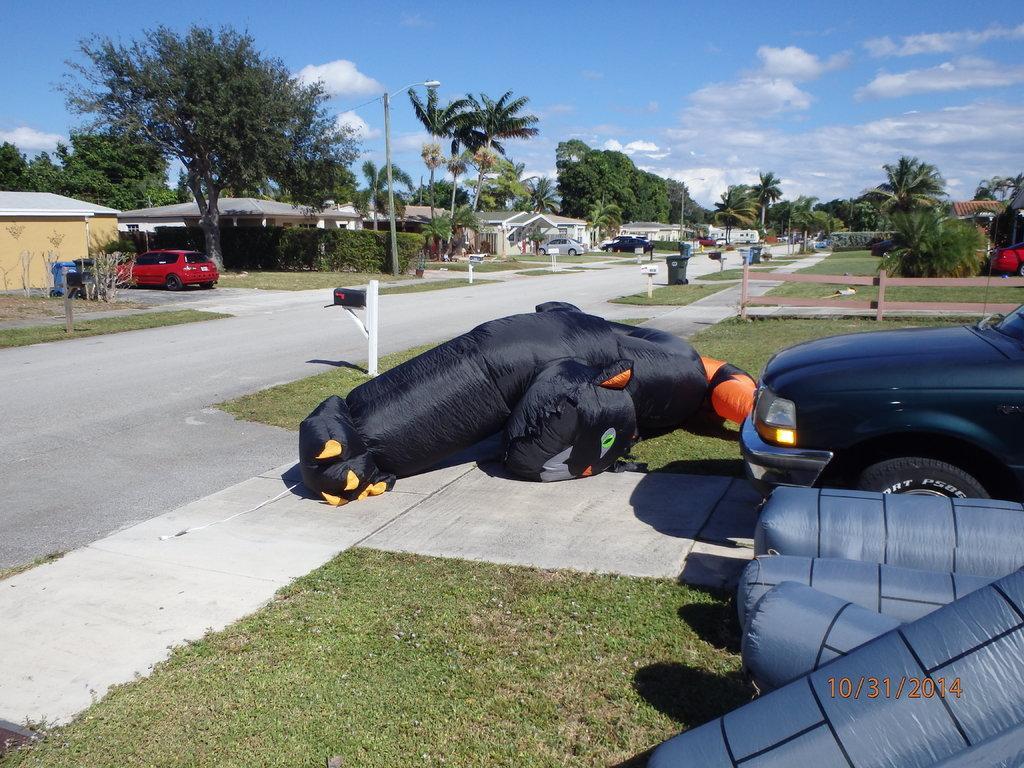Describe this image in one or two sentences. There is a car, a grassy land and other objects are present at the bottom of this image. We can see trees, houses and cars in the background. The cloudy sky is at the top of this image. 